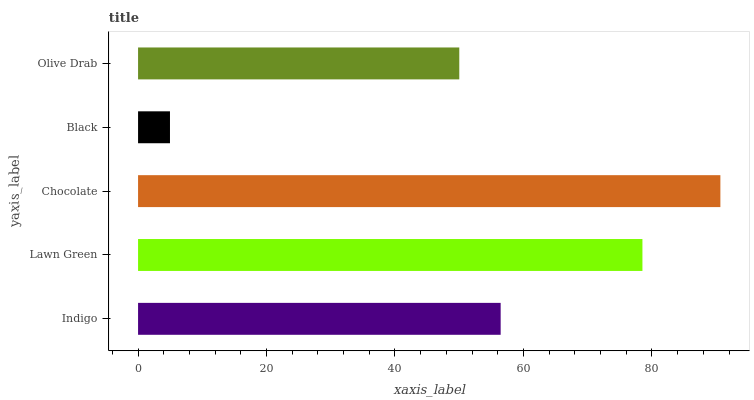Is Black the minimum?
Answer yes or no. Yes. Is Chocolate the maximum?
Answer yes or no. Yes. Is Lawn Green the minimum?
Answer yes or no. No. Is Lawn Green the maximum?
Answer yes or no. No. Is Lawn Green greater than Indigo?
Answer yes or no. Yes. Is Indigo less than Lawn Green?
Answer yes or no. Yes. Is Indigo greater than Lawn Green?
Answer yes or no. No. Is Lawn Green less than Indigo?
Answer yes or no. No. Is Indigo the high median?
Answer yes or no. Yes. Is Indigo the low median?
Answer yes or no. Yes. Is Chocolate the high median?
Answer yes or no. No. Is Chocolate the low median?
Answer yes or no. No. 